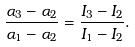Convert formula to latex. <formula><loc_0><loc_0><loc_500><loc_500>\frac { \alpha _ { 3 } - \alpha _ { 2 } } { \alpha _ { 1 } - \alpha _ { 2 } } = \frac { I _ { 3 } - I _ { 2 } } { I _ { 1 } - I _ { 2 } } .</formula> 